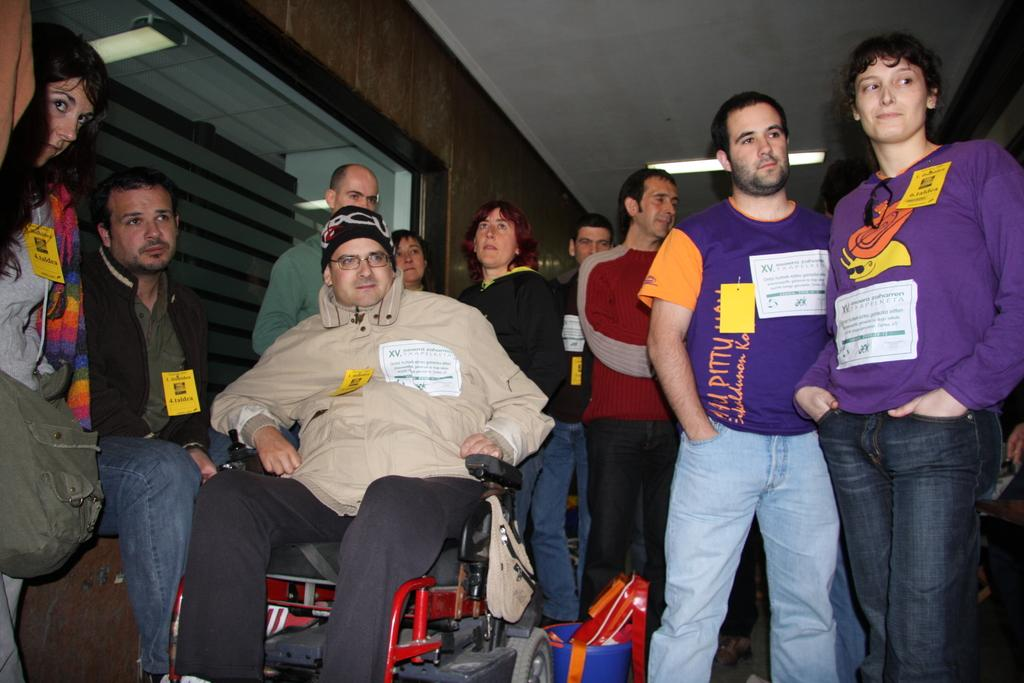How many persons are in the image? There are persons in the image. What is the condition of one of the persons in the image? One person is sitting on a wheelchair. What is visible behind the persons in the image? There is a wall visible behind the persons. What object can be seen in the image that might be used for drinking? There is a glass in the image. What is visible at the top of the image? The roof and a light are visible at the top of the image. Is there a veil covering the person in the wheelchair in the image? There is no veil present in the image, and the person in the wheelchair is not covered by any such object. Can you see any wounds on the persons in the image? There is no indication of any wounds on the persons in the image. 